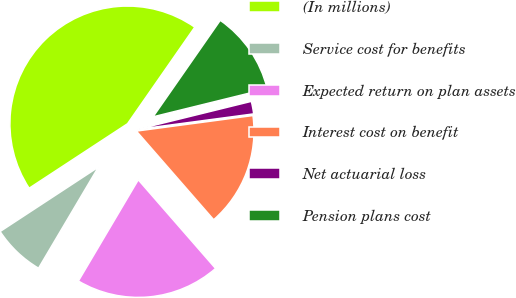Convert chart to OTSL. <chart><loc_0><loc_0><loc_500><loc_500><pie_chart><fcel>(In millions)<fcel>Service cost for benefits<fcel>Expected return on plan assets<fcel>Interest cost on benefit<fcel>Net actuarial loss<fcel>Pension plans cost<nl><fcel>43.92%<fcel>7.26%<fcel>19.92%<fcel>15.7%<fcel>1.73%<fcel>11.48%<nl></chart> 